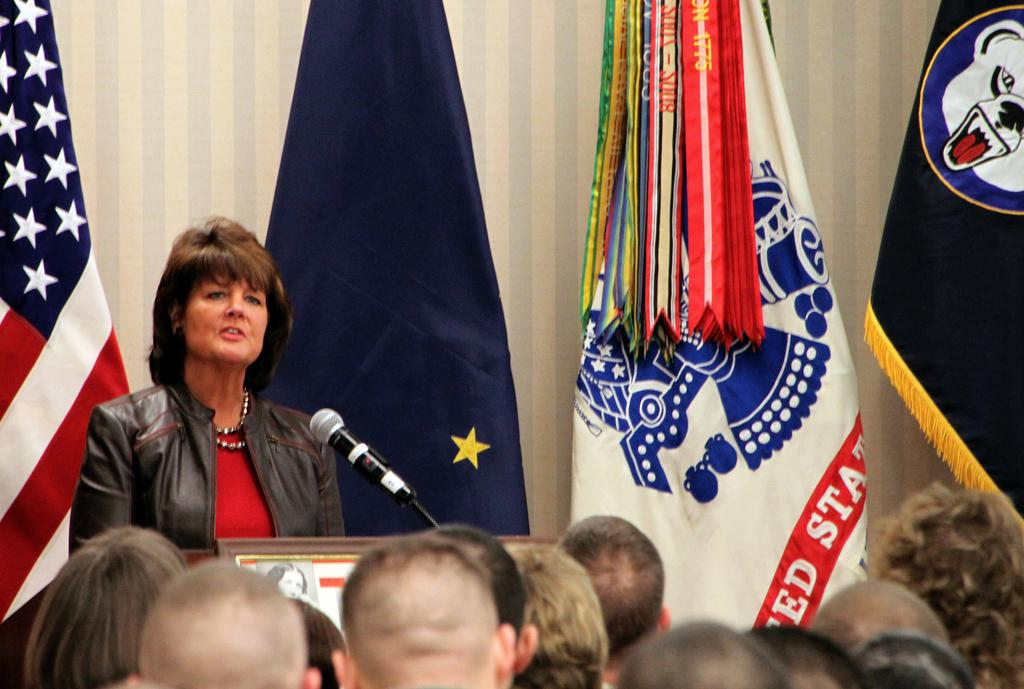How many people are in the image? There are people in the image, but the exact number is not specified. What is the person near the podium doing? The person is standing near a podium and holding a microphone. What can be seen in the background of the image? There are flags and a wall in the background of the image. What type of wren can be seen perched on the microphone in the image? There is no wren present in the image; the person is holding a microphone, but no bird is visible. How many cherries are on the wall in the image? There is no mention of cherries in the image; the background features flags and a wall, but no fruit is visible. 